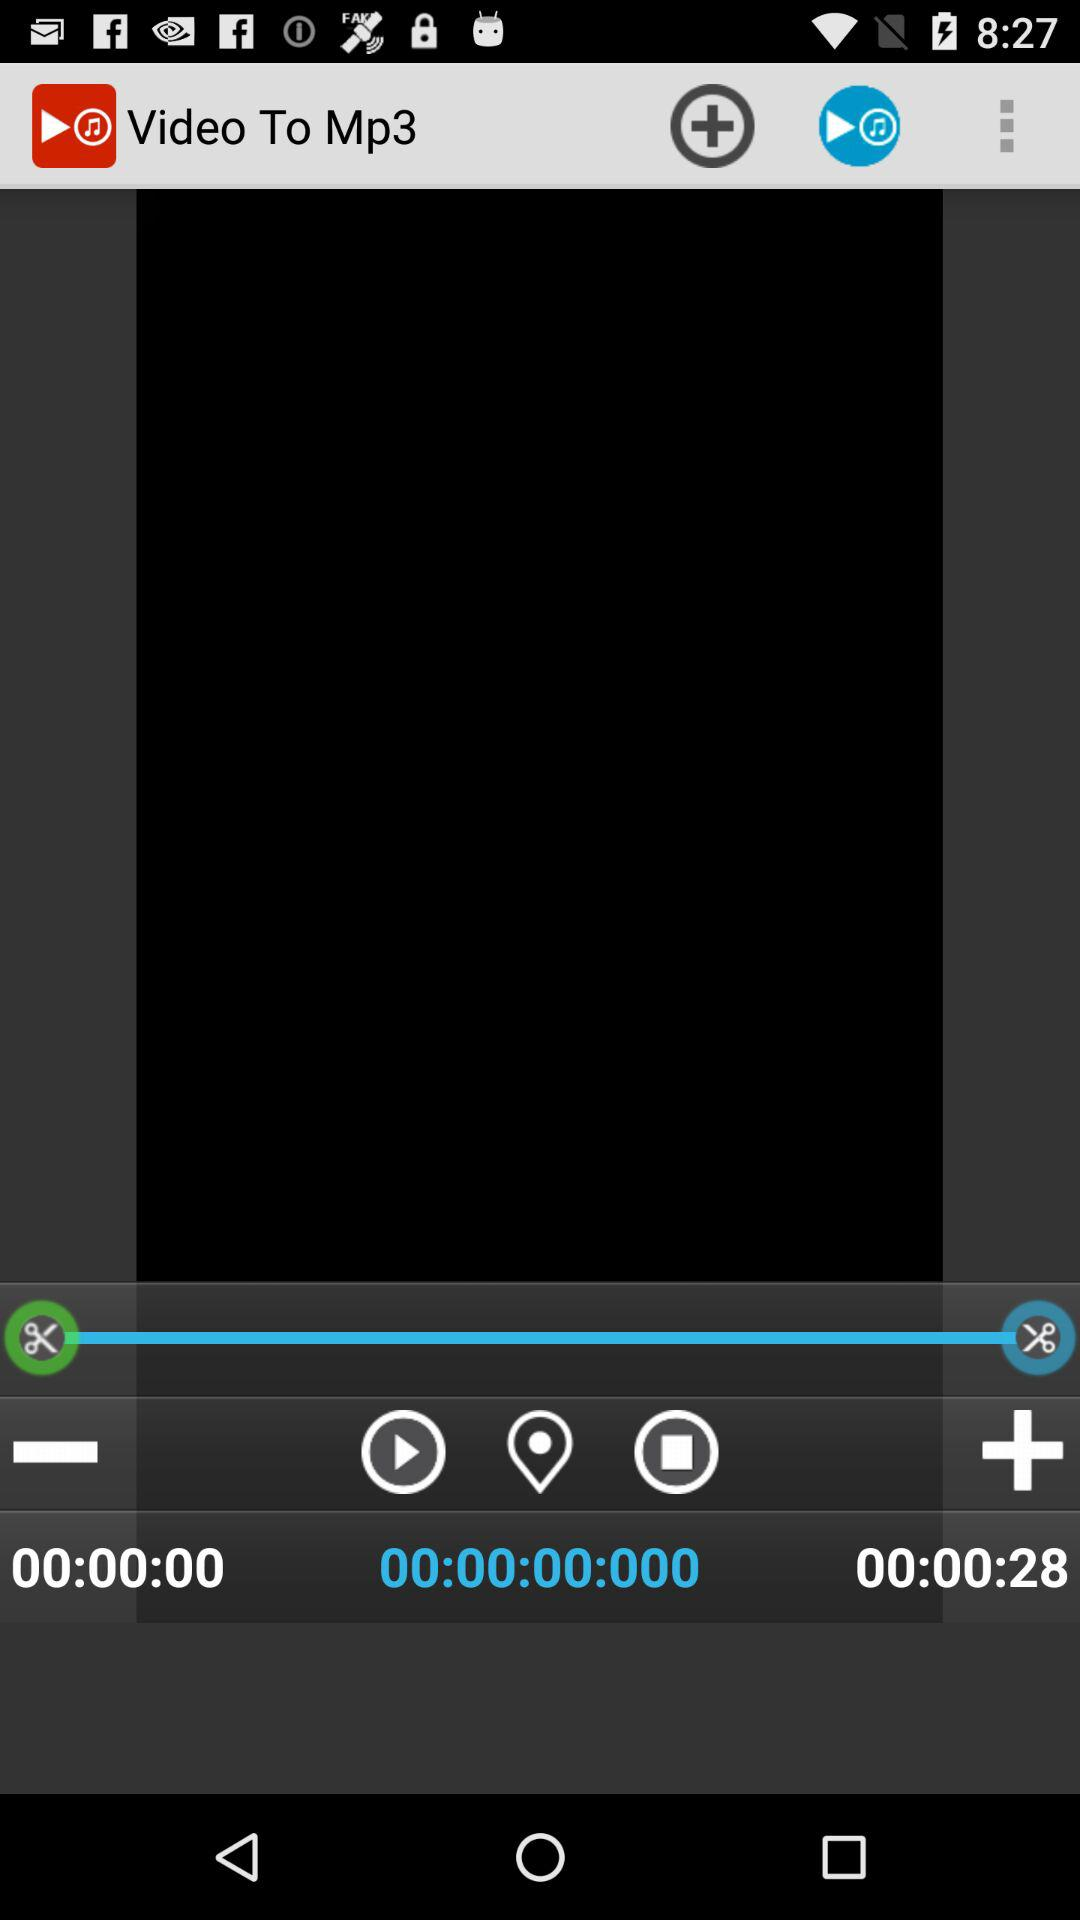How many seconds are there between the first and second timestamps?
Answer the question using a single word or phrase. 28 